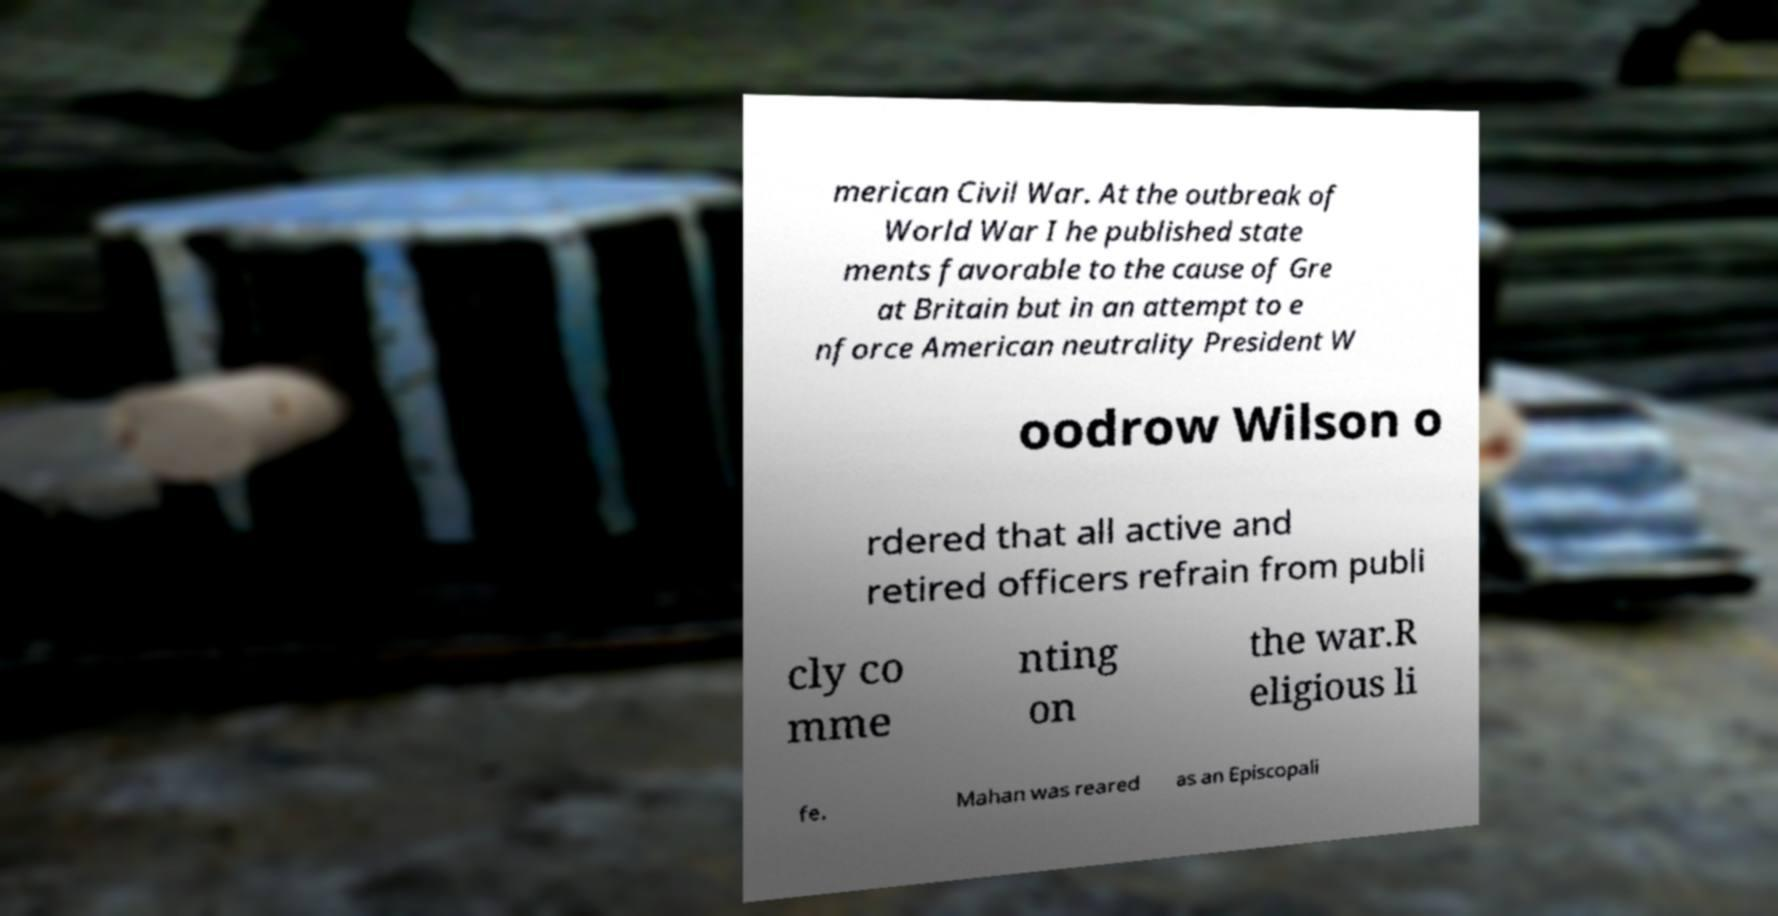Can you accurately transcribe the text from the provided image for me? merican Civil War. At the outbreak of World War I he published state ments favorable to the cause of Gre at Britain but in an attempt to e nforce American neutrality President W oodrow Wilson o rdered that all active and retired officers refrain from publi cly co mme nting on the war.R eligious li fe. Mahan was reared as an Episcopali 